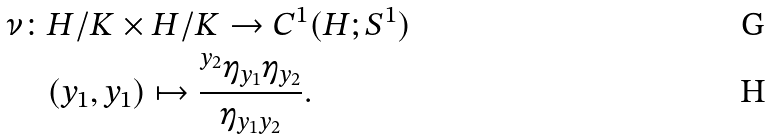<formula> <loc_0><loc_0><loc_500><loc_500>\nu \colon & H / K \times H / K \rightarrow C ^ { 1 } ( H ; S ^ { 1 } ) \\ & ( y _ { 1 } , y _ { 1 } ) \mapsto \frac { { ^ { y _ { 2 } } } \eta _ { y _ { 1 } } \eta _ { y _ { 2 } } } { \eta _ { y _ { 1 } y _ { 2 } } } .</formula> 